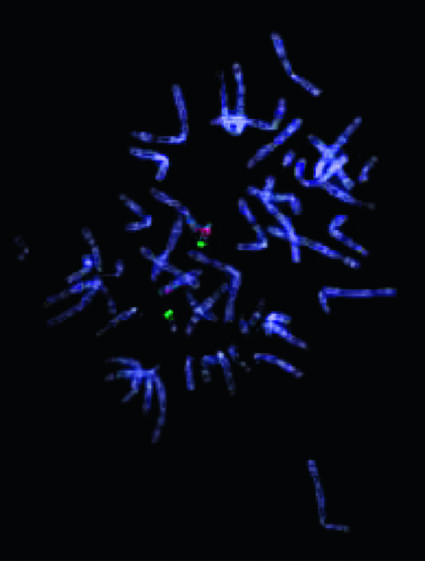what does not stain with the probe for 22q11 .2, indicating a microdeletion in this region?
Answer the question using a single word or phrase. One of the two chromosomes 